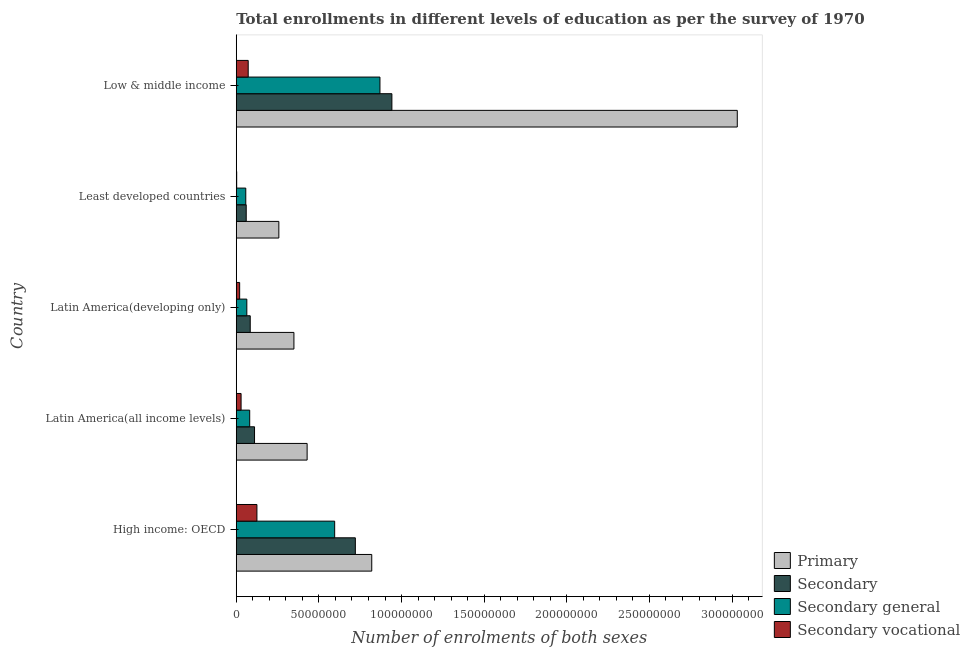Are the number of bars on each tick of the Y-axis equal?
Your answer should be compact. Yes. How many bars are there on the 5th tick from the top?
Keep it short and to the point. 4. What is the label of the 4th group of bars from the top?
Offer a terse response. Latin America(all income levels). In how many cases, is the number of bars for a given country not equal to the number of legend labels?
Your response must be concise. 0. What is the number of enrolments in secondary vocational education in Least developed countries?
Ensure brevity in your answer.  2.60e+05. Across all countries, what is the maximum number of enrolments in secondary general education?
Make the answer very short. 8.69e+07. Across all countries, what is the minimum number of enrolments in secondary vocational education?
Keep it short and to the point. 2.60e+05. In which country was the number of enrolments in primary education minimum?
Your answer should be compact. Least developed countries. What is the total number of enrolments in secondary vocational education in the graph?
Offer a very short reply. 2.50e+07. What is the difference between the number of enrolments in secondary general education in High income: OECD and that in Low & middle income?
Give a very brief answer. -2.74e+07. What is the difference between the number of enrolments in secondary general education in Latin America(developing only) and the number of enrolments in primary education in Latin America(all income levels)?
Keep it short and to the point. -3.65e+07. What is the average number of enrolments in secondary general education per country?
Your response must be concise. 3.34e+07. What is the difference between the number of enrolments in secondary general education and number of enrolments in primary education in Least developed countries?
Make the answer very short. -2.00e+07. In how many countries, is the number of enrolments in secondary vocational education greater than 150000000 ?
Your answer should be compact. 0. What is the ratio of the number of enrolments in secondary general education in Latin America(developing only) to that in Low & middle income?
Your answer should be compact. 0.07. Is the number of enrolments in secondary general education in Latin America(all income levels) less than that in Latin America(developing only)?
Offer a terse response. No. Is the difference between the number of enrolments in secondary general education in Least developed countries and Low & middle income greater than the difference between the number of enrolments in secondary education in Least developed countries and Low & middle income?
Make the answer very short. Yes. What is the difference between the highest and the second highest number of enrolments in secondary education?
Offer a terse response. 2.21e+07. What is the difference between the highest and the lowest number of enrolments in secondary general education?
Your response must be concise. 8.12e+07. Is it the case that in every country, the sum of the number of enrolments in secondary vocational education and number of enrolments in secondary general education is greater than the sum of number of enrolments in secondary education and number of enrolments in primary education?
Make the answer very short. No. What does the 2nd bar from the top in High income: OECD represents?
Your answer should be compact. Secondary general. What does the 4th bar from the bottom in Low & middle income represents?
Provide a succinct answer. Secondary vocational. Is it the case that in every country, the sum of the number of enrolments in primary education and number of enrolments in secondary education is greater than the number of enrolments in secondary general education?
Provide a short and direct response. Yes. How many bars are there?
Your answer should be compact. 20. What is the difference between two consecutive major ticks on the X-axis?
Ensure brevity in your answer.  5.00e+07. Does the graph contain grids?
Provide a short and direct response. No. Where does the legend appear in the graph?
Your response must be concise. Bottom right. What is the title of the graph?
Make the answer very short. Total enrollments in different levels of education as per the survey of 1970. Does "Energy" appear as one of the legend labels in the graph?
Your answer should be compact. No. What is the label or title of the X-axis?
Give a very brief answer. Number of enrolments of both sexes. What is the Number of enrolments of both sexes in Primary in High income: OECD?
Make the answer very short. 8.20e+07. What is the Number of enrolments of both sexes in Secondary in High income: OECD?
Offer a terse response. 7.21e+07. What is the Number of enrolments of both sexes in Secondary general in High income: OECD?
Provide a short and direct response. 5.95e+07. What is the Number of enrolments of both sexes in Secondary vocational in High income: OECD?
Keep it short and to the point. 1.25e+07. What is the Number of enrolments of both sexes in Primary in Latin America(all income levels)?
Offer a terse response. 4.29e+07. What is the Number of enrolments of both sexes in Secondary in Latin America(all income levels)?
Provide a short and direct response. 1.11e+07. What is the Number of enrolments of both sexes of Secondary general in Latin America(all income levels)?
Your answer should be very brief. 8.13e+06. What is the Number of enrolments of both sexes in Secondary vocational in Latin America(all income levels)?
Your response must be concise. 2.92e+06. What is the Number of enrolments of both sexes in Primary in Latin America(developing only)?
Offer a terse response. 3.49e+07. What is the Number of enrolments of both sexes in Secondary in Latin America(developing only)?
Your response must be concise. 8.46e+06. What is the Number of enrolments of both sexes in Secondary general in Latin America(developing only)?
Your response must be concise. 6.39e+06. What is the Number of enrolments of both sexes of Secondary vocational in Latin America(developing only)?
Provide a succinct answer. 2.06e+06. What is the Number of enrolments of both sexes of Primary in Least developed countries?
Provide a short and direct response. 2.58e+07. What is the Number of enrolments of both sexes in Secondary in Least developed countries?
Ensure brevity in your answer.  6.03e+06. What is the Number of enrolments of both sexes of Secondary general in Least developed countries?
Your answer should be compact. 5.76e+06. What is the Number of enrolments of both sexes in Secondary vocational in Least developed countries?
Your answer should be compact. 2.60e+05. What is the Number of enrolments of both sexes of Primary in Low & middle income?
Offer a terse response. 3.03e+08. What is the Number of enrolments of both sexes in Secondary in Low & middle income?
Your answer should be compact. 9.42e+07. What is the Number of enrolments of both sexes in Secondary general in Low & middle income?
Provide a short and direct response. 8.69e+07. What is the Number of enrolments of both sexes in Secondary vocational in Low & middle income?
Offer a terse response. 7.23e+06. Across all countries, what is the maximum Number of enrolments of both sexes in Primary?
Provide a succinct answer. 3.03e+08. Across all countries, what is the maximum Number of enrolments of both sexes of Secondary?
Make the answer very short. 9.42e+07. Across all countries, what is the maximum Number of enrolments of both sexes in Secondary general?
Your answer should be compact. 8.69e+07. Across all countries, what is the maximum Number of enrolments of both sexes in Secondary vocational?
Ensure brevity in your answer.  1.25e+07. Across all countries, what is the minimum Number of enrolments of both sexes of Primary?
Keep it short and to the point. 2.58e+07. Across all countries, what is the minimum Number of enrolments of both sexes in Secondary?
Ensure brevity in your answer.  6.03e+06. Across all countries, what is the minimum Number of enrolments of both sexes in Secondary general?
Your answer should be very brief. 5.76e+06. Across all countries, what is the minimum Number of enrolments of both sexes in Secondary vocational?
Provide a short and direct response. 2.60e+05. What is the total Number of enrolments of both sexes in Primary in the graph?
Your answer should be compact. 4.89e+08. What is the total Number of enrolments of both sexes in Secondary in the graph?
Your response must be concise. 1.92e+08. What is the total Number of enrolments of both sexes of Secondary general in the graph?
Provide a short and direct response. 1.67e+08. What is the total Number of enrolments of both sexes of Secondary vocational in the graph?
Offer a terse response. 2.50e+07. What is the difference between the Number of enrolments of both sexes of Primary in High income: OECD and that in Latin America(all income levels)?
Keep it short and to the point. 3.91e+07. What is the difference between the Number of enrolments of both sexes of Secondary in High income: OECD and that in Latin America(all income levels)?
Provide a succinct answer. 6.10e+07. What is the difference between the Number of enrolments of both sexes of Secondary general in High income: OECD and that in Latin America(all income levels)?
Offer a terse response. 5.14e+07. What is the difference between the Number of enrolments of both sexes of Secondary vocational in High income: OECD and that in Latin America(all income levels)?
Provide a succinct answer. 9.58e+06. What is the difference between the Number of enrolments of both sexes of Primary in High income: OECD and that in Latin America(developing only)?
Give a very brief answer. 4.71e+07. What is the difference between the Number of enrolments of both sexes of Secondary in High income: OECD and that in Latin America(developing only)?
Ensure brevity in your answer.  6.36e+07. What is the difference between the Number of enrolments of both sexes in Secondary general in High income: OECD and that in Latin America(developing only)?
Make the answer very short. 5.32e+07. What is the difference between the Number of enrolments of both sexes in Secondary vocational in High income: OECD and that in Latin America(developing only)?
Ensure brevity in your answer.  1.04e+07. What is the difference between the Number of enrolments of both sexes of Primary in High income: OECD and that in Least developed countries?
Provide a short and direct response. 5.62e+07. What is the difference between the Number of enrolments of both sexes of Secondary in High income: OECD and that in Least developed countries?
Your answer should be very brief. 6.60e+07. What is the difference between the Number of enrolments of both sexes of Secondary general in High income: OECD and that in Least developed countries?
Keep it short and to the point. 5.38e+07. What is the difference between the Number of enrolments of both sexes of Secondary vocational in High income: OECD and that in Least developed countries?
Keep it short and to the point. 1.22e+07. What is the difference between the Number of enrolments of both sexes in Primary in High income: OECD and that in Low & middle income?
Provide a short and direct response. -2.21e+08. What is the difference between the Number of enrolments of both sexes in Secondary in High income: OECD and that in Low & middle income?
Offer a very short reply. -2.21e+07. What is the difference between the Number of enrolments of both sexes in Secondary general in High income: OECD and that in Low & middle income?
Ensure brevity in your answer.  -2.74e+07. What is the difference between the Number of enrolments of both sexes in Secondary vocational in High income: OECD and that in Low & middle income?
Offer a very short reply. 5.28e+06. What is the difference between the Number of enrolments of both sexes in Primary in Latin America(all income levels) and that in Latin America(developing only)?
Give a very brief answer. 7.99e+06. What is the difference between the Number of enrolments of both sexes of Secondary in Latin America(all income levels) and that in Latin America(developing only)?
Make the answer very short. 2.60e+06. What is the difference between the Number of enrolments of both sexes of Secondary general in Latin America(all income levels) and that in Latin America(developing only)?
Provide a short and direct response. 1.74e+06. What is the difference between the Number of enrolments of both sexes in Secondary vocational in Latin America(all income levels) and that in Latin America(developing only)?
Offer a terse response. 8.62e+05. What is the difference between the Number of enrolments of both sexes in Primary in Latin America(all income levels) and that in Least developed countries?
Provide a short and direct response. 1.71e+07. What is the difference between the Number of enrolments of both sexes in Secondary in Latin America(all income levels) and that in Least developed countries?
Provide a short and direct response. 5.03e+06. What is the difference between the Number of enrolments of both sexes in Secondary general in Latin America(all income levels) and that in Least developed countries?
Provide a short and direct response. 2.37e+06. What is the difference between the Number of enrolments of both sexes of Secondary vocational in Latin America(all income levels) and that in Least developed countries?
Give a very brief answer. 2.66e+06. What is the difference between the Number of enrolments of both sexes in Primary in Latin America(all income levels) and that in Low & middle income?
Ensure brevity in your answer.  -2.60e+08. What is the difference between the Number of enrolments of both sexes of Secondary in Latin America(all income levels) and that in Low & middle income?
Ensure brevity in your answer.  -8.31e+07. What is the difference between the Number of enrolments of both sexes in Secondary general in Latin America(all income levels) and that in Low & middle income?
Your answer should be very brief. -7.88e+07. What is the difference between the Number of enrolments of both sexes of Secondary vocational in Latin America(all income levels) and that in Low & middle income?
Make the answer very short. -4.31e+06. What is the difference between the Number of enrolments of both sexes in Primary in Latin America(developing only) and that in Least developed countries?
Provide a succinct answer. 9.12e+06. What is the difference between the Number of enrolments of both sexes in Secondary in Latin America(developing only) and that in Least developed countries?
Provide a short and direct response. 2.43e+06. What is the difference between the Number of enrolments of both sexes of Secondary general in Latin America(developing only) and that in Least developed countries?
Offer a terse response. 6.30e+05. What is the difference between the Number of enrolments of both sexes of Secondary vocational in Latin America(developing only) and that in Least developed countries?
Keep it short and to the point. 1.80e+06. What is the difference between the Number of enrolments of both sexes of Primary in Latin America(developing only) and that in Low & middle income?
Ensure brevity in your answer.  -2.68e+08. What is the difference between the Number of enrolments of both sexes of Secondary in Latin America(developing only) and that in Low & middle income?
Your answer should be compact. -8.57e+07. What is the difference between the Number of enrolments of both sexes of Secondary general in Latin America(developing only) and that in Low & middle income?
Give a very brief answer. -8.06e+07. What is the difference between the Number of enrolments of both sexes in Secondary vocational in Latin America(developing only) and that in Low & middle income?
Your answer should be very brief. -5.17e+06. What is the difference between the Number of enrolments of both sexes of Primary in Least developed countries and that in Low & middle income?
Ensure brevity in your answer.  -2.77e+08. What is the difference between the Number of enrolments of both sexes of Secondary in Least developed countries and that in Low & middle income?
Offer a terse response. -8.81e+07. What is the difference between the Number of enrolments of both sexes of Secondary general in Least developed countries and that in Low & middle income?
Keep it short and to the point. -8.12e+07. What is the difference between the Number of enrolments of both sexes of Secondary vocational in Least developed countries and that in Low & middle income?
Your answer should be very brief. -6.97e+06. What is the difference between the Number of enrolments of both sexes of Primary in High income: OECD and the Number of enrolments of both sexes of Secondary in Latin America(all income levels)?
Provide a succinct answer. 7.09e+07. What is the difference between the Number of enrolments of both sexes of Primary in High income: OECD and the Number of enrolments of both sexes of Secondary general in Latin America(all income levels)?
Your answer should be very brief. 7.39e+07. What is the difference between the Number of enrolments of both sexes of Primary in High income: OECD and the Number of enrolments of both sexes of Secondary vocational in Latin America(all income levels)?
Offer a very short reply. 7.91e+07. What is the difference between the Number of enrolments of both sexes in Secondary in High income: OECD and the Number of enrolments of both sexes in Secondary general in Latin America(all income levels)?
Your answer should be very brief. 6.39e+07. What is the difference between the Number of enrolments of both sexes in Secondary in High income: OECD and the Number of enrolments of both sexes in Secondary vocational in Latin America(all income levels)?
Your answer should be very brief. 6.91e+07. What is the difference between the Number of enrolments of both sexes of Secondary general in High income: OECD and the Number of enrolments of both sexes of Secondary vocational in Latin America(all income levels)?
Provide a succinct answer. 5.66e+07. What is the difference between the Number of enrolments of both sexes of Primary in High income: OECD and the Number of enrolments of both sexes of Secondary in Latin America(developing only)?
Your answer should be compact. 7.35e+07. What is the difference between the Number of enrolments of both sexes of Primary in High income: OECD and the Number of enrolments of both sexes of Secondary general in Latin America(developing only)?
Offer a very short reply. 7.56e+07. What is the difference between the Number of enrolments of both sexes in Primary in High income: OECD and the Number of enrolments of both sexes in Secondary vocational in Latin America(developing only)?
Your answer should be very brief. 7.99e+07. What is the difference between the Number of enrolments of both sexes of Secondary in High income: OECD and the Number of enrolments of both sexes of Secondary general in Latin America(developing only)?
Offer a very short reply. 6.57e+07. What is the difference between the Number of enrolments of both sexes of Secondary in High income: OECD and the Number of enrolments of both sexes of Secondary vocational in Latin America(developing only)?
Provide a short and direct response. 7.00e+07. What is the difference between the Number of enrolments of both sexes in Secondary general in High income: OECD and the Number of enrolments of both sexes in Secondary vocational in Latin America(developing only)?
Your answer should be compact. 5.75e+07. What is the difference between the Number of enrolments of both sexes in Primary in High income: OECD and the Number of enrolments of both sexes in Secondary in Least developed countries?
Provide a succinct answer. 7.60e+07. What is the difference between the Number of enrolments of both sexes in Primary in High income: OECD and the Number of enrolments of both sexes in Secondary general in Least developed countries?
Make the answer very short. 7.62e+07. What is the difference between the Number of enrolments of both sexes of Primary in High income: OECD and the Number of enrolments of both sexes of Secondary vocational in Least developed countries?
Make the answer very short. 8.17e+07. What is the difference between the Number of enrolments of both sexes in Secondary in High income: OECD and the Number of enrolments of both sexes in Secondary general in Least developed countries?
Your answer should be compact. 6.63e+07. What is the difference between the Number of enrolments of both sexes of Secondary in High income: OECD and the Number of enrolments of both sexes of Secondary vocational in Least developed countries?
Give a very brief answer. 7.18e+07. What is the difference between the Number of enrolments of both sexes of Secondary general in High income: OECD and the Number of enrolments of both sexes of Secondary vocational in Least developed countries?
Provide a short and direct response. 5.93e+07. What is the difference between the Number of enrolments of both sexes in Primary in High income: OECD and the Number of enrolments of both sexes in Secondary in Low & middle income?
Your response must be concise. -1.22e+07. What is the difference between the Number of enrolments of both sexes of Primary in High income: OECD and the Number of enrolments of both sexes of Secondary general in Low & middle income?
Your answer should be compact. -4.96e+06. What is the difference between the Number of enrolments of both sexes of Primary in High income: OECD and the Number of enrolments of both sexes of Secondary vocational in Low & middle income?
Provide a succinct answer. 7.48e+07. What is the difference between the Number of enrolments of both sexes in Secondary in High income: OECD and the Number of enrolments of both sexes in Secondary general in Low & middle income?
Keep it short and to the point. -1.49e+07. What is the difference between the Number of enrolments of both sexes in Secondary in High income: OECD and the Number of enrolments of both sexes in Secondary vocational in Low & middle income?
Keep it short and to the point. 6.48e+07. What is the difference between the Number of enrolments of both sexes of Secondary general in High income: OECD and the Number of enrolments of both sexes of Secondary vocational in Low & middle income?
Your answer should be very brief. 5.23e+07. What is the difference between the Number of enrolments of both sexes of Primary in Latin America(all income levels) and the Number of enrolments of both sexes of Secondary in Latin America(developing only)?
Keep it short and to the point. 3.44e+07. What is the difference between the Number of enrolments of both sexes of Primary in Latin America(all income levels) and the Number of enrolments of both sexes of Secondary general in Latin America(developing only)?
Provide a succinct answer. 3.65e+07. What is the difference between the Number of enrolments of both sexes in Primary in Latin America(all income levels) and the Number of enrolments of both sexes in Secondary vocational in Latin America(developing only)?
Give a very brief answer. 4.08e+07. What is the difference between the Number of enrolments of both sexes of Secondary in Latin America(all income levels) and the Number of enrolments of both sexes of Secondary general in Latin America(developing only)?
Provide a short and direct response. 4.66e+06. What is the difference between the Number of enrolments of both sexes in Secondary in Latin America(all income levels) and the Number of enrolments of both sexes in Secondary vocational in Latin America(developing only)?
Your answer should be very brief. 9.00e+06. What is the difference between the Number of enrolments of both sexes of Secondary general in Latin America(all income levels) and the Number of enrolments of both sexes of Secondary vocational in Latin America(developing only)?
Offer a very short reply. 6.07e+06. What is the difference between the Number of enrolments of both sexes of Primary in Latin America(all income levels) and the Number of enrolments of both sexes of Secondary in Least developed countries?
Ensure brevity in your answer.  3.69e+07. What is the difference between the Number of enrolments of both sexes in Primary in Latin America(all income levels) and the Number of enrolments of both sexes in Secondary general in Least developed countries?
Give a very brief answer. 3.71e+07. What is the difference between the Number of enrolments of both sexes of Primary in Latin America(all income levels) and the Number of enrolments of both sexes of Secondary vocational in Least developed countries?
Your answer should be very brief. 4.26e+07. What is the difference between the Number of enrolments of both sexes of Secondary in Latin America(all income levels) and the Number of enrolments of both sexes of Secondary general in Least developed countries?
Your answer should be very brief. 5.29e+06. What is the difference between the Number of enrolments of both sexes in Secondary in Latin America(all income levels) and the Number of enrolments of both sexes in Secondary vocational in Least developed countries?
Make the answer very short. 1.08e+07. What is the difference between the Number of enrolments of both sexes in Secondary general in Latin America(all income levels) and the Number of enrolments of both sexes in Secondary vocational in Least developed countries?
Your answer should be compact. 7.87e+06. What is the difference between the Number of enrolments of both sexes of Primary in Latin America(all income levels) and the Number of enrolments of both sexes of Secondary in Low & middle income?
Give a very brief answer. -5.13e+07. What is the difference between the Number of enrolments of both sexes of Primary in Latin America(all income levels) and the Number of enrolments of both sexes of Secondary general in Low & middle income?
Your response must be concise. -4.41e+07. What is the difference between the Number of enrolments of both sexes in Primary in Latin America(all income levels) and the Number of enrolments of both sexes in Secondary vocational in Low & middle income?
Offer a very short reply. 3.57e+07. What is the difference between the Number of enrolments of both sexes of Secondary in Latin America(all income levels) and the Number of enrolments of both sexes of Secondary general in Low & middle income?
Offer a terse response. -7.59e+07. What is the difference between the Number of enrolments of both sexes of Secondary in Latin America(all income levels) and the Number of enrolments of both sexes of Secondary vocational in Low & middle income?
Provide a succinct answer. 3.83e+06. What is the difference between the Number of enrolments of both sexes of Secondary general in Latin America(all income levels) and the Number of enrolments of both sexes of Secondary vocational in Low & middle income?
Your answer should be very brief. 9.06e+05. What is the difference between the Number of enrolments of both sexes in Primary in Latin America(developing only) and the Number of enrolments of both sexes in Secondary in Least developed countries?
Keep it short and to the point. 2.89e+07. What is the difference between the Number of enrolments of both sexes of Primary in Latin America(developing only) and the Number of enrolments of both sexes of Secondary general in Least developed countries?
Offer a terse response. 2.91e+07. What is the difference between the Number of enrolments of both sexes of Primary in Latin America(developing only) and the Number of enrolments of both sexes of Secondary vocational in Least developed countries?
Your response must be concise. 3.46e+07. What is the difference between the Number of enrolments of both sexes in Secondary in Latin America(developing only) and the Number of enrolments of both sexes in Secondary general in Least developed countries?
Your answer should be compact. 2.69e+06. What is the difference between the Number of enrolments of both sexes in Secondary in Latin America(developing only) and the Number of enrolments of both sexes in Secondary vocational in Least developed countries?
Ensure brevity in your answer.  8.20e+06. What is the difference between the Number of enrolments of both sexes in Secondary general in Latin America(developing only) and the Number of enrolments of both sexes in Secondary vocational in Least developed countries?
Provide a short and direct response. 6.13e+06. What is the difference between the Number of enrolments of both sexes in Primary in Latin America(developing only) and the Number of enrolments of both sexes in Secondary in Low & middle income?
Offer a very short reply. -5.93e+07. What is the difference between the Number of enrolments of both sexes in Primary in Latin America(developing only) and the Number of enrolments of both sexes in Secondary general in Low & middle income?
Provide a succinct answer. -5.21e+07. What is the difference between the Number of enrolments of both sexes in Primary in Latin America(developing only) and the Number of enrolments of both sexes in Secondary vocational in Low & middle income?
Give a very brief answer. 2.77e+07. What is the difference between the Number of enrolments of both sexes in Secondary in Latin America(developing only) and the Number of enrolments of both sexes in Secondary general in Low & middle income?
Give a very brief answer. -7.85e+07. What is the difference between the Number of enrolments of both sexes of Secondary in Latin America(developing only) and the Number of enrolments of both sexes of Secondary vocational in Low & middle income?
Offer a terse response. 1.23e+06. What is the difference between the Number of enrolments of both sexes of Secondary general in Latin America(developing only) and the Number of enrolments of both sexes of Secondary vocational in Low & middle income?
Give a very brief answer. -8.34e+05. What is the difference between the Number of enrolments of both sexes in Primary in Least developed countries and the Number of enrolments of both sexes in Secondary in Low & middle income?
Give a very brief answer. -6.84e+07. What is the difference between the Number of enrolments of both sexes in Primary in Least developed countries and the Number of enrolments of both sexes in Secondary general in Low & middle income?
Your answer should be very brief. -6.12e+07. What is the difference between the Number of enrolments of both sexes in Primary in Least developed countries and the Number of enrolments of both sexes in Secondary vocational in Low & middle income?
Ensure brevity in your answer.  1.85e+07. What is the difference between the Number of enrolments of both sexes in Secondary in Least developed countries and the Number of enrolments of both sexes in Secondary general in Low & middle income?
Give a very brief answer. -8.09e+07. What is the difference between the Number of enrolments of both sexes of Secondary in Least developed countries and the Number of enrolments of both sexes of Secondary vocational in Low & middle income?
Keep it short and to the point. -1.20e+06. What is the difference between the Number of enrolments of both sexes of Secondary general in Least developed countries and the Number of enrolments of both sexes of Secondary vocational in Low & middle income?
Your answer should be compact. -1.46e+06. What is the average Number of enrolments of both sexes of Primary per country?
Provide a short and direct response. 9.77e+07. What is the average Number of enrolments of both sexes in Secondary per country?
Provide a short and direct response. 3.84e+07. What is the average Number of enrolments of both sexes in Secondary general per country?
Ensure brevity in your answer.  3.34e+07. What is the average Number of enrolments of both sexes of Secondary vocational per country?
Ensure brevity in your answer.  5.00e+06. What is the difference between the Number of enrolments of both sexes of Primary and Number of enrolments of both sexes of Secondary in High income: OECD?
Provide a short and direct response. 9.93e+06. What is the difference between the Number of enrolments of both sexes in Primary and Number of enrolments of both sexes in Secondary general in High income: OECD?
Provide a succinct answer. 2.24e+07. What is the difference between the Number of enrolments of both sexes in Primary and Number of enrolments of both sexes in Secondary vocational in High income: OECD?
Ensure brevity in your answer.  6.95e+07. What is the difference between the Number of enrolments of both sexes of Secondary and Number of enrolments of both sexes of Secondary general in High income: OECD?
Make the answer very short. 1.25e+07. What is the difference between the Number of enrolments of both sexes of Secondary and Number of enrolments of both sexes of Secondary vocational in High income: OECD?
Make the answer very short. 5.95e+07. What is the difference between the Number of enrolments of both sexes of Secondary general and Number of enrolments of both sexes of Secondary vocational in High income: OECD?
Provide a short and direct response. 4.70e+07. What is the difference between the Number of enrolments of both sexes in Primary and Number of enrolments of both sexes in Secondary in Latin America(all income levels)?
Your response must be concise. 3.18e+07. What is the difference between the Number of enrolments of both sexes of Primary and Number of enrolments of both sexes of Secondary general in Latin America(all income levels)?
Offer a terse response. 3.48e+07. What is the difference between the Number of enrolments of both sexes of Primary and Number of enrolments of both sexes of Secondary vocational in Latin America(all income levels)?
Your answer should be compact. 4.00e+07. What is the difference between the Number of enrolments of both sexes of Secondary and Number of enrolments of both sexes of Secondary general in Latin America(all income levels)?
Offer a very short reply. 2.92e+06. What is the difference between the Number of enrolments of both sexes in Secondary and Number of enrolments of both sexes in Secondary vocational in Latin America(all income levels)?
Offer a very short reply. 8.13e+06. What is the difference between the Number of enrolments of both sexes in Secondary general and Number of enrolments of both sexes in Secondary vocational in Latin America(all income levels)?
Provide a short and direct response. 5.21e+06. What is the difference between the Number of enrolments of both sexes of Primary and Number of enrolments of both sexes of Secondary in Latin America(developing only)?
Your response must be concise. 2.64e+07. What is the difference between the Number of enrolments of both sexes of Primary and Number of enrolments of both sexes of Secondary general in Latin America(developing only)?
Your response must be concise. 2.85e+07. What is the difference between the Number of enrolments of both sexes in Primary and Number of enrolments of both sexes in Secondary vocational in Latin America(developing only)?
Make the answer very short. 3.28e+07. What is the difference between the Number of enrolments of both sexes of Secondary and Number of enrolments of both sexes of Secondary general in Latin America(developing only)?
Your answer should be very brief. 2.06e+06. What is the difference between the Number of enrolments of both sexes in Secondary and Number of enrolments of both sexes in Secondary vocational in Latin America(developing only)?
Give a very brief answer. 6.39e+06. What is the difference between the Number of enrolments of both sexes of Secondary general and Number of enrolments of both sexes of Secondary vocational in Latin America(developing only)?
Your response must be concise. 4.33e+06. What is the difference between the Number of enrolments of both sexes in Primary and Number of enrolments of both sexes in Secondary in Least developed countries?
Provide a succinct answer. 1.97e+07. What is the difference between the Number of enrolments of both sexes of Primary and Number of enrolments of both sexes of Secondary general in Least developed countries?
Your answer should be very brief. 2.00e+07. What is the difference between the Number of enrolments of both sexes of Primary and Number of enrolments of both sexes of Secondary vocational in Least developed countries?
Provide a succinct answer. 2.55e+07. What is the difference between the Number of enrolments of both sexes of Secondary and Number of enrolments of both sexes of Secondary general in Least developed countries?
Provide a succinct answer. 2.60e+05. What is the difference between the Number of enrolments of both sexes in Secondary and Number of enrolments of both sexes in Secondary vocational in Least developed countries?
Keep it short and to the point. 5.76e+06. What is the difference between the Number of enrolments of both sexes in Secondary general and Number of enrolments of both sexes in Secondary vocational in Least developed countries?
Provide a succinct answer. 5.50e+06. What is the difference between the Number of enrolments of both sexes in Primary and Number of enrolments of both sexes in Secondary in Low & middle income?
Offer a terse response. 2.09e+08. What is the difference between the Number of enrolments of both sexes in Primary and Number of enrolments of both sexes in Secondary general in Low & middle income?
Provide a succinct answer. 2.16e+08. What is the difference between the Number of enrolments of both sexes of Primary and Number of enrolments of both sexes of Secondary vocational in Low & middle income?
Make the answer very short. 2.96e+08. What is the difference between the Number of enrolments of both sexes of Secondary and Number of enrolments of both sexes of Secondary general in Low & middle income?
Your answer should be compact. 7.23e+06. What is the difference between the Number of enrolments of both sexes in Secondary and Number of enrolments of both sexes in Secondary vocational in Low & middle income?
Provide a short and direct response. 8.69e+07. What is the difference between the Number of enrolments of both sexes of Secondary general and Number of enrolments of both sexes of Secondary vocational in Low & middle income?
Offer a terse response. 7.97e+07. What is the ratio of the Number of enrolments of both sexes of Primary in High income: OECD to that in Latin America(all income levels)?
Offer a terse response. 1.91. What is the ratio of the Number of enrolments of both sexes in Secondary in High income: OECD to that in Latin America(all income levels)?
Your answer should be very brief. 6.52. What is the ratio of the Number of enrolments of both sexes in Secondary general in High income: OECD to that in Latin America(all income levels)?
Your response must be concise. 7.32. What is the ratio of the Number of enrolments of both sexes in Secondary vocational in High income: OECD to that in Latin America(all income levels)?
Your response must be concise. 4.28. What is the ratio of the Number of enrolments of both sexes of Primary in High income: OECD to that in Latin America(developing only)?
Keep it short and to the point. 2.35. What is the ratio of the Number of enrolments of both sexes in Secondary in High income: OECD to that in Latin America(developing only)?
Your answer should be compact. 8.52. What is the ratio of the Number of enrolments of both sexes of Secondary general in High income: OECD to that in Latin America(developing only)?
Provide a succinct answer. 9.31. What is the ratio of the Number of enrolments of both sexes in Secondary vocational in High income: OECD to that in Latin America(developing only)?
Ensure brevity in your answer.  6.07. What is the ratio of the Number of enrolments of both sexes in Primary in High income: OECD to that in Least developed countries?
Ensure brevity in your answer.  3.18. What is the ratio of the Number of enrolments of both sexes of Secondary in High income: OECD to that in Least developed countries?
Your response must be concise. 11.96. What is the ratio of the Number of enrolments of both sexes of Secondary general in High income: OECD to that in Least developed countries?
Provide a short and direct response. 10.33. What is the ratio of the Number of enrolments of both sexes of Secondary vocational in High income: OECD to that in Least developed countries?
Make the answer very short. 48.08. What is the ratio of the Number of enrolments of both sexes of Primary in High income: OECD to that in Low & middle income?
Give a very brief answer. 0.27. What is the ratio of the Number of enrolments of both sexes in Secondary in High income: OECD to that in Low & middle income?
Give a very brief answer. 0.77. What is the ratio of the Number of enrolments of both sexes of Secondary general in High income: OECD to that in Low & middle income?
Give a very brief answer. 0.68. What is the ratio of the Number of enrolments of both sexes in Secondary vocational in High income: OECD to that in Low & middle income?
Offer a very short reply. 1.73. What is the ratio of the Number of enrolments of both sexes in Primary in Latin America(all income levels) to that in Latin America(developing only)?
Provide a short and direct response. 1.23. What is the ratio of the Number of enrolments of both sexes of Secondary in Latin America(all income levels) to that in Latin America(developing only)?
Your answer should be very brief. 1.31. What is the ratio of the Number of enrolments of both sexes of Secondary general in Latin America(all income levels) to that in Latin America(developing only)?
Make the answer very short. 1.27. What is the ratio of the Number of enrolments of both sexes in Secondary vocational in Latin America(all income levels) to that in Latin America(developing only)?
Make the answer very short. 1.42. What is the ratio of the Number of enrolments of both sexes of Primary in Latin America(all income levels) to that in Least developed countries?
Give a very brief answer. 1.66. What is the ratio of the Number of enrolments of both sexes of Secondary in Latin America(all income levels) to that in Least developed countries?
Your answer should be very brief. 1.84. What is the ratio of the Number of enrolments of both sexes of Secondary general in Latin America(all income levels) to that in Least developed countries?
Keep it short and to the point. 1.41. What is the ratio of the Number of enrolments of both sexes in Secondary vocational in Latin America(all income levels) to that in Least developed countries?
Your answer should be compact. 11.24. What is the ratio of the Number of enrolments of both sexes in Primary in Latin America(all income levels) to that in Low & middle income?
Keep it short and to the point. 0.14. What is the ratio of the Number of enrolments of both sexes in Secondary in Latin America(all income levels) to that in Low & middle income?
Your answer should be compact. 0.12. What is the ratio of the Number of enrolments of both sexes of Secondary general in Latin America(all income levels) to that in Low & middle income?
Your answer should be very brief. 0.09. What is the ratio of the Number of enrolments of both sexes in Secondary vocational in Latin America(all income levels) to that in Low & middle income?
Make the answer very short. 0.4. What is the ratio of the Number of enrolments of both sexes in Primary in Latin America(developing only) to that in Least developed countries?
Make the answer very short. 1.35. What is the ratio of the Number of enrolments of both sexes of Secondary in Latin America(developing only) to that in Least developed countries?
Provide a short and direct response. 1.4. What is the ratio of the Number of enrolments of both sexes in Secondary general in Latin America(developing only) to that in Least developed countries?
Give a very brief answer. 1.11. What is the ratio of the Number of enrolments of both sexes of Secondary vocational in Latin America(developing only) to that in Least developed countries?
Provide a short and direct response. 7.92. What is the ratio of the Number of enrolments of both sexes of Primary in Latin America(developing only) to that in Low & middle income?
Ensure brevity in your answer.  0.12. What is the ratio of the Number of enrolments of both sexes in Secondary in Latin America(developing only) to that in Low & middle income?
Your response must be concise. 0.09. What is the ratio of the Number of enrolments of both sexes in Secondary general in Latin America(developing only) to that in Low & middle income?
Your response must be concise. 0.07. What is the ratio of the Number of enrolments of both sexes of Secondary vocational in Latin America(developing only) to that in Low & middle income?
Provide a short and direct response. 0.29. What is the ratio of the Number of enrolments of both sexes in Primary in Least developed countries to that in Low & middle income?
Offer a very short reply. 0.09. What is the ratio of the Number of enrolments of both sexes of Secondary in Least developed countries to that in Low & middle income?
Your answer should be compact. 0.06. What is the ratio of the Number of enrolments of both sexes in Secondary general in Least developed countries to that in Low & middle income?
Provide a short and direct response. 0.07. What is the ratio of the Number of enrolments of both sexes of Secondary vocational in Least developed countries to that in Low & middle income?
Your answer should be very brief. 0.04. What is the difference between the highest and the second highest Number of enrolments of both sexes in Primary?
Provide a succinct answer. 2.21e+08. What is the difference between the highest and the second highest Number of enrolments of both sexes of Secondary?
Offer a terse response. 2.21e+07. What is the difference between the highest and the second highest Number of enrolments of both sexes of Secondary general?
Your answer should be compact. 2.74e+07. What is the difference between the highest and the second highest Number of enrolments of both sexes in Secondary vocational?
Provide a short and direct response. 5.28e+06. What is the difference between the highest and the lowest Number of enrolments of both sexes in Primary?
Offer a terse response. 2.77e+08. What is the difference between the highest and the lowest Number of enrolments of both sexes in Secondary?
Your response must be concise. 8.81e+07. What is the difference between the highest and the lowest Number of enrolments of both sexes in Secondary general?
Your response must be concise. 8.12e+07. What is the difference between the highest and the lowest Number of enrolments of both sexes in Secondary vocational?
Provide a succinct answer. 1.22e+07. 